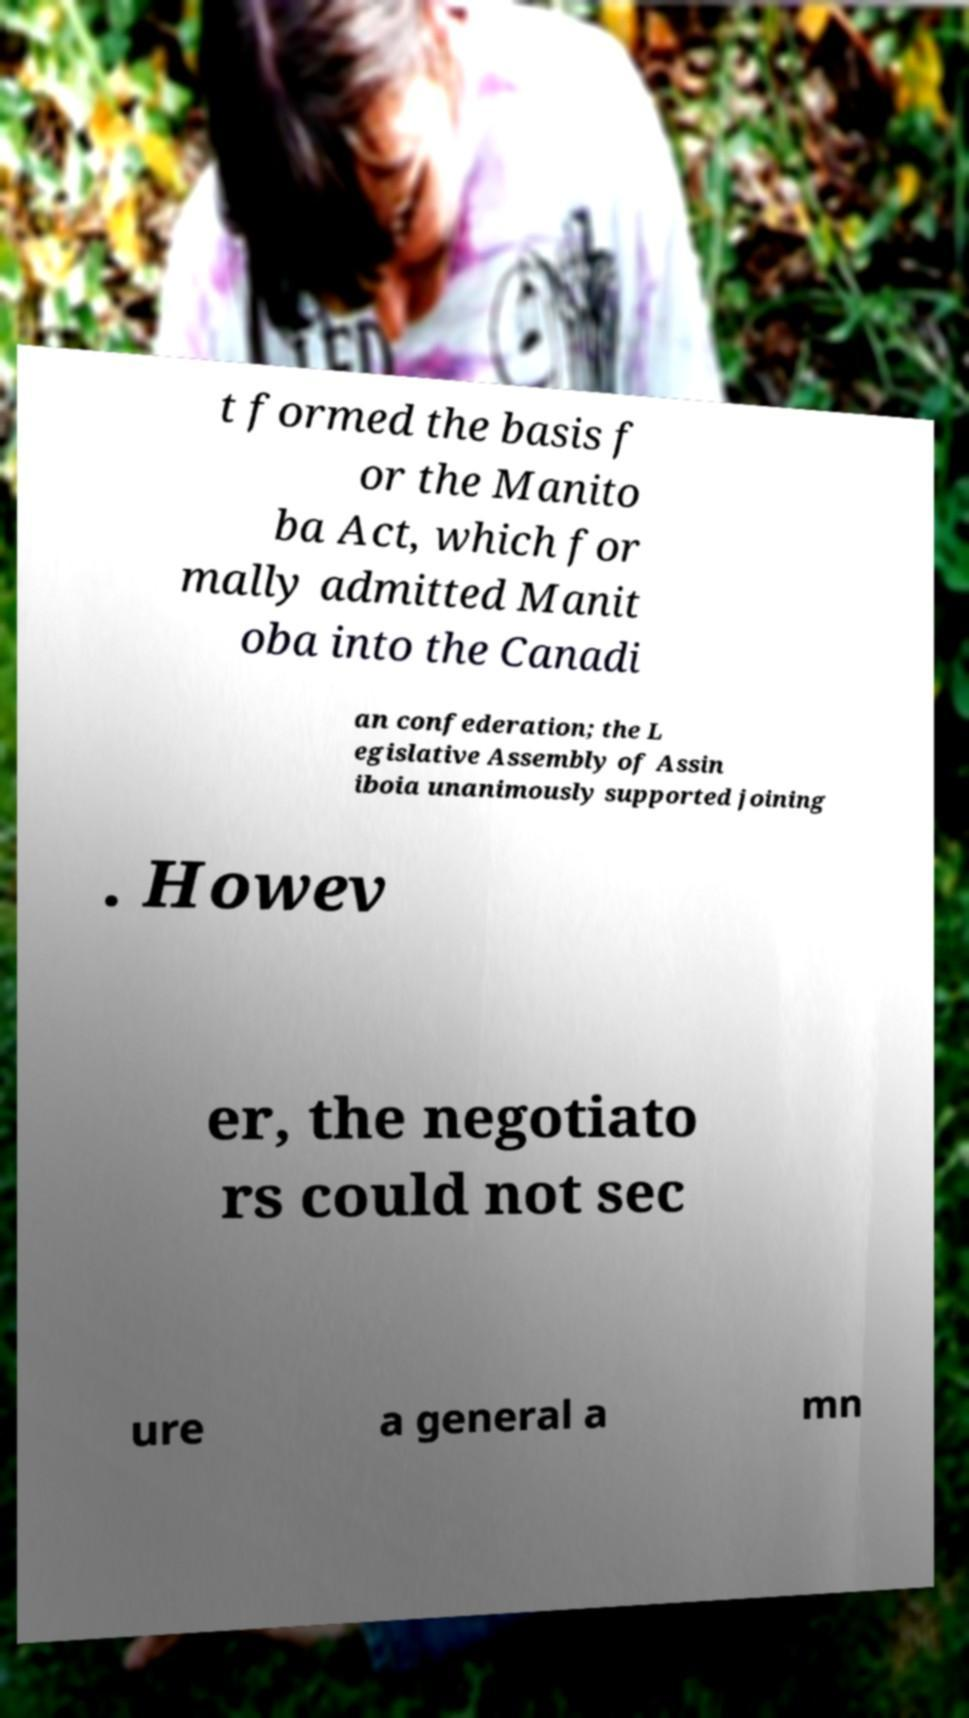Could you extract and type out the text from this image? t formed the basis f or the Manito ba Act, which for mally admitted Manit oba into the Canadi an confederation; the L egislative Assembly of Assin iboia unanimously supported joining . Howev er, the negotiato rs could not sec ure a general a mn 